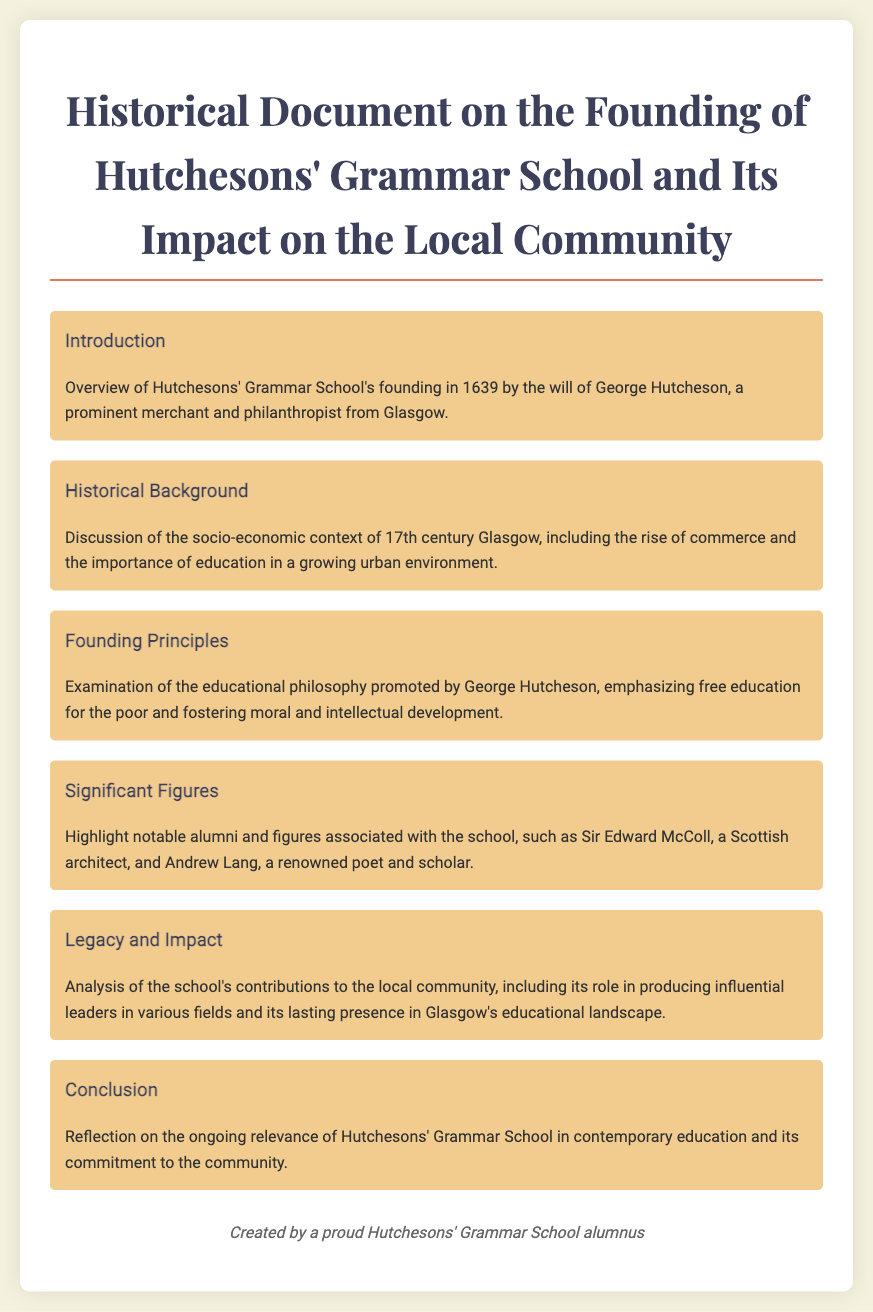What year was Hutchesons' Grammar School founded? The text explicitly states that Hutchesons' Grammar School was founded in 1639.
Answer: 1639 Who founded Hutchesons' Grammar School? The overview mentions that the school was founded by George Hutcheson, a prominent merchant and philanthropist.
Answer: George Hutcheson What was emphasized in George Hutcheson's educational philosophy? The document notes that his educational philosophy emphasized free education for the poor.
Answer: Free education for the poor Name a notable figure associated with Hutchesons' Grammar School. The document highlights Sir Edward McColl as a notable alumni figure associated with the school.
Answer: Sir Edward McColl What is a key role of Hutchesons' Grammar School in the local community? The analysis states that the school contributes to producing influential leaders in various fields.
Answer: Producing influential leaders What is the main focus of the 'Legacy and Impact' section? The section analyzes the school's contributions to the local community and its lasting presence in the educational landscape.
Answer: Contributions to the local community What year does the document reflect upon concerning the ongoing relevance of Hutchesons' Grammar School? While it discusses its ongoing relevance, the document does not specify a particular year, focusing instead on contemporary education.
Answer: Contemporary education Which style of education was promoted by George Hutcheson? The historical background discusses the importance of education in a growing urban environment and highlights moral and intellectual development.
Answer: Moral and intellectual development What is the title of the first section of the document? The first section is titled 'Introduction,' where the founding is overviewed.
Answer: Introduction 